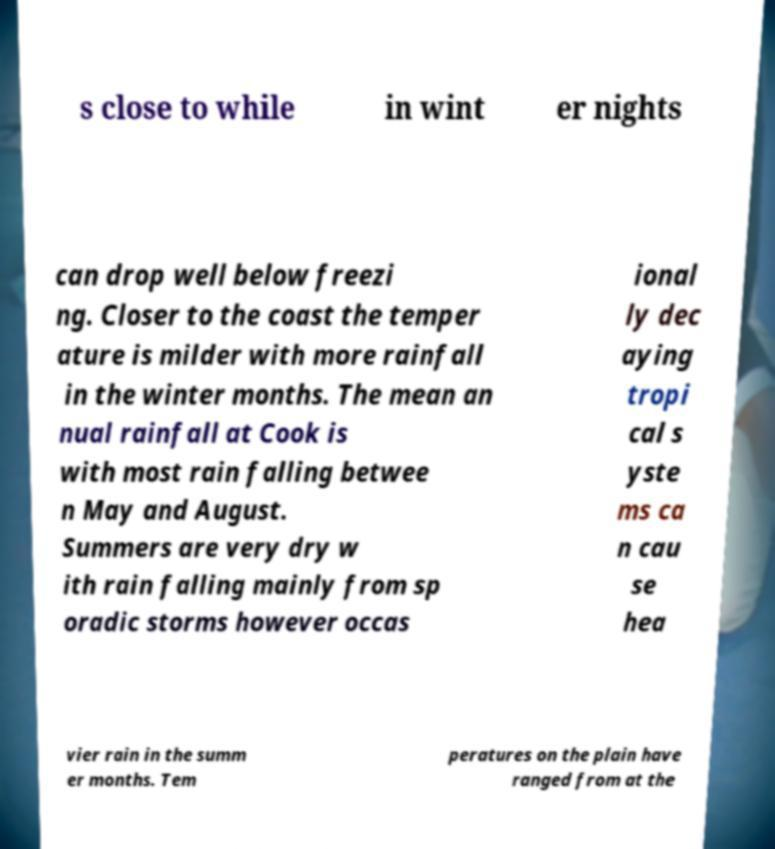For documentation purposes, I need the text within this image transcribed. Could you provide that? s close to while in wint er nights can drop well below freezi ng. Closer to the coast the temper ature is milder with more rainfall in the winter months. The mean an nual rainfall at Cook is with most rain falling betwee n May and August. Summers are very dry w ith rain falling mainly from sp oradic storms however occas ional ly dec aying tropi cal s yste ms ca n cau se hea vier rain in the summ er months. Tem peratures on the plain have ranged from at the 